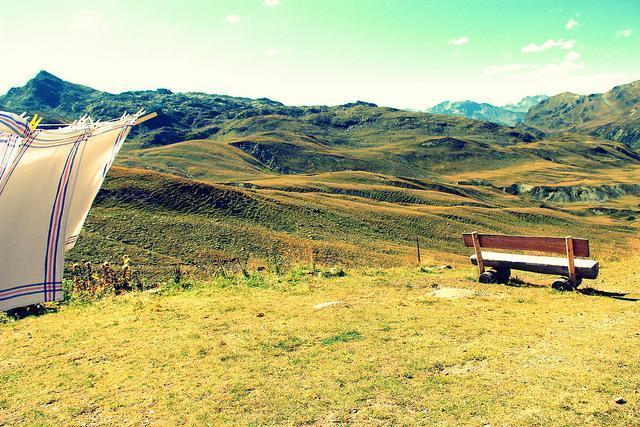How many men are making a two-fingered sign?
Give a very brief answer. 0. 